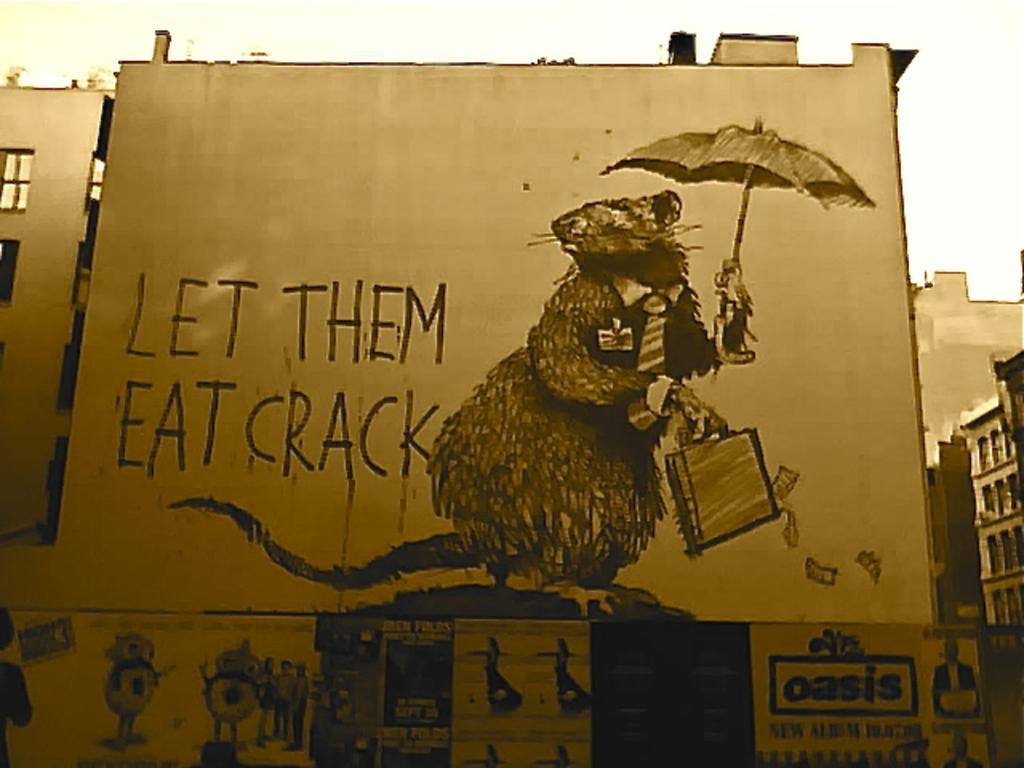In one or two sentences, can you explain what this image depicts? In the foreground of this image, there are few posters on the wall at the bottom. In the middle, there are paintings of a rat holding a suitcase and an umbrella with some text on the wall. On either side, there are buildings. At the top, there is the sky. 